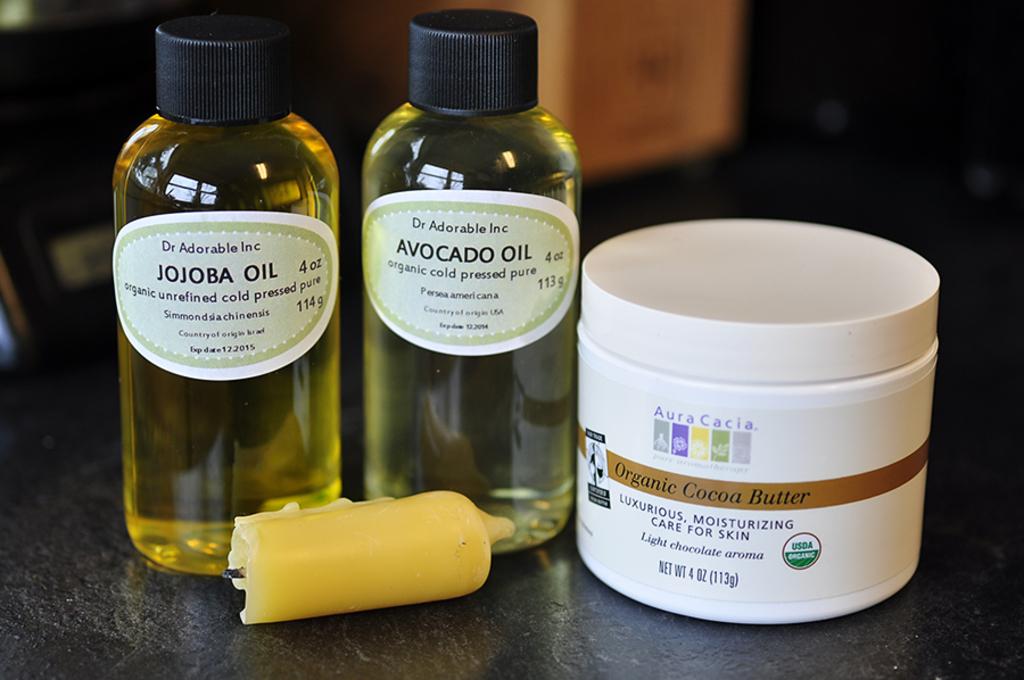What kinda of butter is in the container?
Keep it short and to the point. Organic cocoa. 